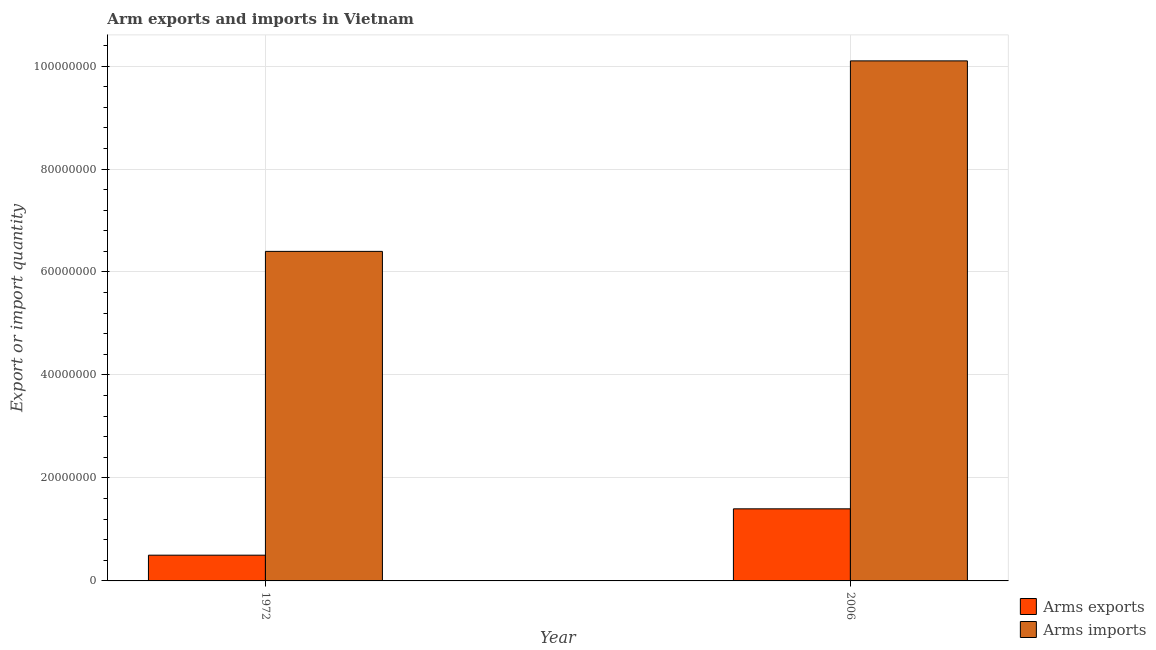How many groups of bars are there?
Your response must be concise. 2. Are the number of bars per tick equal to the number of legend labels?
Provide a short and direct response. Yes. How many bars are there on the 2nd tick from the left?
Keep it short and to the point. 2. How many bars are there on the 2nd tick from the right?
Offer a terse response. 2. What is the label of the 2nd group of bars from the left?
Offer a very short reply. 2006. In how many cases, is the number of bars for a given year not equal to the number of legend labels?
Provide a short and direct response. 0. What is the arms exports in 1972?
Give a very brief answer. 5.00e+06. Across all years, what is the maximum arms imports?
Offer a very short reply. 1.01e+08. Across all years, what is the minimum arms imports?
Provide a succinct answer. 6.40e+07. What is the total arms exports in the graph?
Keep it short and to the point. 1.90e+07. What is the difference between the arms exports in 1972 and that in 2006?
Your answer should be very brief. -9.00e+06. What is the difference between the arms exports in 2006 and the arms imports in 1972?
Provide a short and direct response. 9.00e+06. What is the average arms exports per year?
Your answer should be compact. 9.50e+06. What is the ratio of the arms imports in 1972 to that in 2006?
Your answer should be compact. 0.63. Is the arms imports in 1972 less than that in 2006?
Ensure brevity in your answer.  Yes. In how many years, is the arms exports greater than the average arms exports taken over all years?
Make the answer very short. 1. What does the 2nd bar from the left in 1972 represents?
Ensure brevity in your answer.  Arms imports. What does the 1st bar from the right in 2006 represents?
Make the answer very short. Arms imports. How many bars are there?
Keep it short and to the point. 4. Are all the bars in the graph horizontal?
Offer a terse response. No. How many years are there in the graph?
Keep it short and to the point. 2. Are the values on the major ticks of Y-axis written in scientific E-notation?
Provide a succinct answer. No. Does the graph contain any zero values?
Give a very brief answer. No. How many legend labels are there?
Ensure brevity in your answer.  2. How are the legend labels stacked?
Give a very brief answer. Vertical. What is the title of the graph?
Give a very brief answer. Arm exports and imports in Vietnam. What is the label or title of the X-axis?
Give a very brief answer. Year. What is the label or title of the Y-axis?
Your answer should be very brief. Export or import quantity. What is the Export or import quantity in Arms imports in 1972?
Your response must be concise. 6.40e+07. What is the Export or import quantity of Arms exports in 2006?
Offer a terse response. 1.40e+07. What is the Export or import quantity in Arms imports in 2006?
Your answer should be compact. 1.01e+08. Across all years, what is the maximum Export or import quantity in Arms exports?
Ensure brevity in your answer.  1.40e+07. Across all years, what is the maximum Export or import quantity of Arms imports?
Ensure brevity in your answer.  1.01e+08. Across all years, what is the minimum Export or import quantity in Arms exports?
Give a very brief answer. 5.00e+06. Across all years, what is the minimum Export or import quantity in Arms imports?
Ensure brevity in your answer.  6.40e+07. What is the total Export or import quantity in Arms exports in the graph?
Provide a succinct answer. 1.90e+07. What is the total Export or import quantity in Arms imports in the graph?
Ensure brevity in your answer.  1.65e+08. What is the difference between the Export or import quantity in Arms exports in 1972 and that in 2006?
Provide a succinct answer. -9.00e+06. What is the difference between the Export or import quantity of Arms imports in 1972 and that in 2006?
Ensure brevity in your answer.  -3.70e+07. What is the difference between the Export or import quantity of Arms exports in 1972 and the Export or import quantity of Arms imports in 2006?
Make the answer very short. -9.60e+07. What is the average Export or import quantity in Arms exports per year?
Keep it short and to the point. 9.50e+06. What is the average Export or import quantity in Arms imports per year?
Offer a terse response. 8.25e+07. In the year 1972, what is the difference between the Export or import quantity in Arms exports and Export or import quantity in Arms imports?
Offer a terse response. -5.90e+07. In the year 2006, what is the difference between the Export or import quantity in Arms exports and Export or import quantity in Arms imports?
Provide a succinct answer. -8.70e+07. What is the ratio of the Export or import quantity in Arms exports in 1972 to that in 2006?
Provide a short and direct response. 0.36. What is the ratio of the Export or import quantity in Arms imports in 1972 to that in 2006?
Provide a short and direct response. 0.63. What is the difference between the highest and the second highest Export or import quantity in Arms exports?
Provide a short and direct response. 9.00e+06. What is the difference between the highest and the second highest Export or import quantity in Arms imports?
Make the answer very short. 3.70e+07. What is the difference between the highest and the lowest Export or import quantity in Arms exports?
Your answer should be compact. 9.00e+06. What is the difference between the highest and the lowest Export or import quantity of Arms imports?
Make the answer very short. 3.70e+07. 